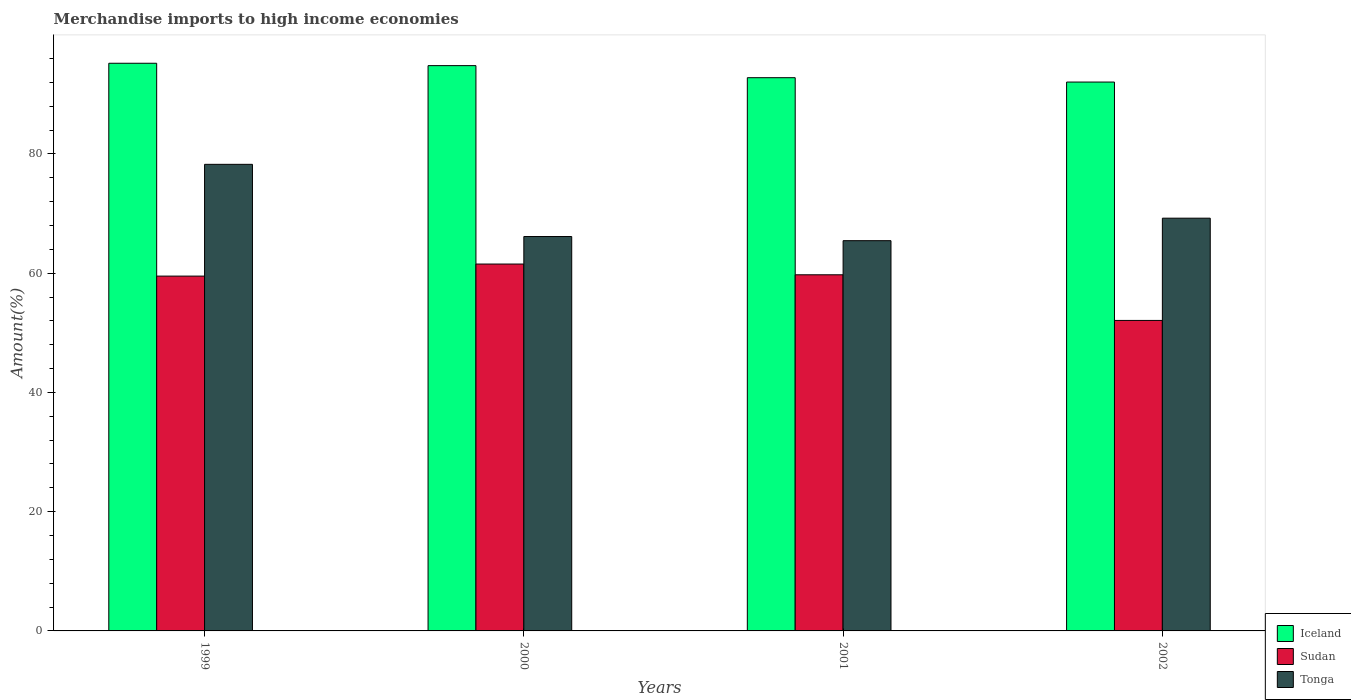How many different coloured bars are there?
Provide a short and direct response. 3. How many groups of bars are there?
Give a very brief answer. 4. Are the number of bars per tick equal to the number of legend labels?
Offer a very short reply. Yes. Are the number of bars on each tick of the X-axis equal?
Provide a short and direct response. Yes. How many bars are there on the 3rd tick from the right?
Keep it short and to the point. 3. What is the label of the 3rd group of bars from the left?
Your answer should be very brief. 2001. In how many cases, is the number of bars for a given year not equal to the number of legend labels?
Give a very brief answer. 0. What is the percentage of amount earned from merchandise imports in Tonga in 2000?
Provide a short and direct response. 66.15. Across all years, what is the maximum percentage of amount earned from merchandise imports in Tonga?
Your response must be concise. 78.26. Across all years, what is the minimum percentage of amount earned from merchandise imports in Iceland?
Your answer should be compact. 92.06. What is the total percentage of amount earned from merchandise imports in Sudan in the graph?
Offer a terse response. 232.85. What is the difference between the percentage of amount earned from merchandise imports in Sudan in 1999 and that in 2002?
Make the answer very short. 7.43. What is the difference between the percentage of amount earned from merchandise imports in Tonga in 2000 and the percentage of amount earned from merchandise imports in Iceland in 1999?
Make the answer very short. -29.06. What is the average percentage of amount earned from merchandise imports in Sudan per year?
Your answer should be compact. 58.21. In the year 2001, what is the difference between the percentage of amount earned from merchandise imports in Sudan and percentage of amount earned from merchandise imports in Iceland?
Provide a succinct answer. -33.05. In how many years, is the percentage of amount earned from merchandise imports in Iceland greater than 84 %?
Offer a very short reply. 4. What is the ratio of the percentage of amount earned from merchandise imports in Tonga in 2001 to that in 2002?
Give a very brief answer. 0.95. Is the difference between the percentage of amount earned from merchandise imports in Sudan in 1999 and 2002 greater than the difference between the percentage of amount earned from merchandise imports in Iceland in 1999 and 2002?
Provide a short and direct response. Yes. What is the difference between the highest and the second highest percentage of amount earned from merchandise imports in Sudan?
Your response must be concise. 1.8. What is the difference between the highest and the lowest percentage of amount earned from merchandise imports in Iceland?
Offer a very short reply. 3.15. In how many years, is the percentage of amount earned from merchandise imports in Sudan greater than the average percentage of amount earned from merchandise imports in Sudan taken over all years?
Give a very brief answer. 3. Is the sum of the percentage of amount earned from merchandise imports in Iceland in 2001 and 2002 greater than the maximum percentage of amount earned from merchandise imports in Sudan across all years?
Provide a succinct answer. Yes. What does the 3rd bar from the left in 2001 represents?
Make the answer very short. Tonga. Does the graph contain any zero values?
Make the answer very short. No. Does the graph contain grids?
Your answer should be very brief. No. Where does the legend appear in the graph?
Provide a short and direct response. Bottom right. What is the title of the graph?
Offer a terse response. Merchandise imports to high income economies. Does "Montenegro" appear as one of the legend labels in the graph?
Make the answer very short. No. What is the label or title of the Y-axis?
Provide a succinct answer. Amount(%). What is the Amount(%) of Iceland in 1999?
Make the answer very short. 95.21. What is the Amount(%) in Sudan in 1999?
Provide a short and direct response. 59.51. What is the Amount(%) of Tonga in 1999?
Your response must be concise. 78.26. What is the Amount(%) of Iceland in 2000?
Offer a very short reply. 94.81. What is the Amount(%) in Sudan in 2000?
Make the answer very short. 61.53. What is the Amount(%) in Tonga in 2000?
Keep it short and to the point. 66.15. What is the Amount(%) in Iceland in 2001?
Give a very brief answer. 92.79. What is the Amount(%) in Sudan in 2001?
Keep it short and to the point. 59.73. What is the Amount(%) of Tonga in 2001?
Offer a very short reply. 65.45. What is the Amount(%) in Iceland in 2002?
Make the answer very short. 92.06. What is the Amount(%) in Sudan in 2002?
Your answer should be compact. 52.08. What is the Amount(%) in Tonga in 2002?
Provide a succinct answer. 69.22. Across all years, what is the maximum Amount(%) of Iceland?
Your answer should be compact. 95.21. Across all years, what is the maximum Amount(%) of Sudan?
Keep it short and to the point. 61.53. Across all years, what is the maximum Amount(%) of Tonga?
Offer a terse response. 78.26. Across all years, what is the minimum Amount(%) of Iceland?
Provide a succinct answer. 92.06. Across all years, what is the minimum Amount(%) of Sudan?
Provide a short and direct response. 52.08. Across all years, what is the minimum Amount(%) in Tonga?
Offer a very short reply. 65.45. What is the total Amount(%) of Iceland in the graph?
Your answer should be compact. 374.86. What is the total Amount(%) in Sudan in the graph?
Offer a very short reply. 232.85. What is the total Amount(%) in Tonga in the graph?
Your response must be concise. 279.08. What is the difference between the Amount(%) of Iceland in 1999 and that in 2000?
Your response must be concise. 0.4. What is the difference between the Amount(%) in Sudan in 1999 and that in 2000?
Offer a very short reply. -2.02. What is the difference between the Amount(%) in Tonga in 1999 and that in 2000?
Your answer should be compact. 12.11. What is the difference between the Amount(%) in Iceland in 1999 and that in 2001?
Ensure brevity in your answer.  2.42. What is the difference between the Amount(%) in Sudan in 1999 and that in 2001?
Make the answer very short. -0.22. What is the difference between the Amount(%) of Tonga in 1999 and that in 2001?
Offer a very short reply. 12.8. What is the difference between the Amount(%) of Iceland in 1999 and that in 2002?
Your answer should be very brief. 3.15. What is the difference between the Amount(%) of Sudan in 1999 and that in 2002?
Your response must be concise. 7.43. What is the difference between the Amount(%) of Tonga in 1999 and that in 2002?
Provide a succinct answer. 9.03. What is the difference between the Amount(%) in Iceland in 2000 and that in 2001?
Provide a short and direct response. 2.02. What is the difference between the Amount(%) of Sudan in 2000 and that in 2001?
Offer a very short reply. 1.8. What is the difference between the Amount(%) in Tonga in 2000 and that in 2001?
Provide a succinct answer. 0.7. What is the difference between the Amount(%) of Iceland in 2000 and that in 2002?
Ensure brevity in your answer.  2.76. What is the difference between the Amount(%) in Sudan in 2000 and that in 2002?
Your response must be concise. 9.46. What is the difference between the Amount(%) in Tonga in 2000 and that in 2002?
Offer a very short reply. -3.08. What is the difference between the Amount(%) of Iceland in 2001 and that in 2002?
Ensure brevity in your answer.  0.73. What is the difference between the Amount(%) in Sudan in 2001 and that in 2002?
Offer a very short reply. 7.66. What is the difference between the Amount(%) of Tonga in 2001 and that in 2002?
Make the answer very short. -3.77. What is the difference between the Amount(%) of Iceland in 1999 and the Amount(%) of Sudan in 2000?
Your answer should be compact. 33.67. What is the difference between the Amount(%) of Iceland in 1999 and the Amount(%) of Tonga in 2000?
Your answer should be compact. 29.06. What is the difference between the Amount(%) of Sudan in 1999 and the Amount(%) of Tonga in 2000?
Provide a succinct answer. -6.64. What is the difference between the Amount(%) in Iceland in 1999 and the Amount(%) in Sudan in 2001?
Ensure brevity in your answer.  35.48. What is the difference between the Amount(%) of Iceland in 1999 and the Amount(%) of Tonga in 2001?
Offer a terse response. 29.76. What is the difference between the Amount(%) of Sudan in 1999 and the Amount(%) of Tonga in 2001?
Keep it short and to the point. -5.94. What is the difference between the Amount(%) in Iceland in 1999 and the Amount(%) in Sudan in 2002?
Give a very brief answer. 43.13. What is the difference between the Amount(%) of Iceland in 1999 and the Amount(%) of Tonga in 2002?
Make the answer very short. 25.98. What is the difference between the Amount(%) in Sudan in 1999 and the Amount(%) in Tonga in 2002?
Your answer should be compact. -9.71. What is the difference between the Amount(%) in Iceland in 2000 and the Amount(%) in Sudan in 2001?
Your response must be concise. 35.08. What is the difference between the Amount(%) in Iceland in 2000 and the Amount(%) in Tonga in 2001?
Give a very brief answer. 29.36. What is the difference between the Amount(%) of Sudan in 2000 and the Amount(%) of Tonga in 2001?
Make the answer very short. -3.92. What is the difference between the Amount(%) of Iceland in 2000 and the Amount(%) of Sudan in 2002?
Provide a short and direct response. 42.73. What is the difference between the Amount(%) of Iceland in 2000 and the Amount(%) of Tonga in 2002?
Keep it short and to the point. 25.59. What is the difference between the Amount(%) in Sudan in 2000 and the Amount(%) in Tonga in 2002?
Ensure brevity in your answer.  -7.69. What is the difference between the Amount(%) of Iceland in 2001 and the Amount(%) of Sudan in 2002?
Give a very brief answer. 40.71. What is the difference between the Amount(%) of Iceland in 2001 and the Amount(%) of Tonga in 2002?
Offer a terse response. 23.56. What is the difference between the Amount(%) of Sudan in 2001 and the Amount(%) of Tonga in 2002?
Make the answer very short. -9.49. What is the average Amount(%) of Iceland per year?
Give a very brief answer. 93.72. What is the average Amount(%) of Sudan per year?
Provide a short and direct response. 58.21. What is the average Amount(%) in Tonga per year?
Your answer should be compact. 69.77. In the year 1999, what is the difference between the Amount(%) in Iceland and Amount(%) in Sudan?
Give a very brief answer. 35.7. In the year 1999, what is the difference between the Amount(%) of Iceland and Amount(%) of Tonga?
Offer a terse response. 16.95. In the year 1999, what is the difference between the Amount(%) of Sudan and Amount(%) of Tonga?
Keep it short and to the point. -18.75. In the year 2000, what is the difference between the Amount(%) in Iceland and Amount(%) in Sudan?
Offer a terse response. 33.28. In the year 2000, what is the difference between the Amount(%) in Iceland and Amount(%) in Tonga?
Make the answer very short. 28.66. In the year 2000, what is the difference between the Amount(%) in Sudan and Amount(%) in Tonga?
Offer a very short reply. -4.61. In the year 2001, what is the difference between the Amount(%) of Iceland and Amount(%) of Sudan?
Keep it short and to the point. 33.05. In the year 2001, what is the difference between the Amount(%) of Iceland and Amount(%) of Tonga?
Offer a very short reply. 27.33. In the year 2001, what is the difference between the Amount(%) in Sudan and Amount(%) in Tonga?
Give a very brief answer. -5.72. In the year 2002, what is the difference between the Amount(%) of Iceland and Amount(%) of Sudan?
Ensure brevity in your answer.  39.98. In the year 2002, what is the difference between the Amount(%) of Iceland and Amount(%) of Tonga?
Offer a terse response. 22.83. In the year 2002, what is the difference between the Amount(%) in Sudan and Amount(%) in Tonga?
Provide a succinct answer. -17.15. What is the ratio of the Amount(%) of Sudan in 1999 to that in 2000?
Offer a terse response. 0.97. What is the ratio of the Amount(%) of Tonga in 1999 to that in 2000?
Give a very brief answer. 1.18. What is the ratio of the Amount(%) of Iceland in 1999 to that in 2001?
Your answer should be compact. 1.03. What is the ratio of the Amount(%) of Tonga in 1999 to that in 2001?
Provide a succinct answer. 1.2. What is the ratio of the Amount(%) of Iceland in 1999 to that in 2002?
Your answer should be very brief. 1.03. What is the ratio of the Amount(%) of Sudan in 1999 to that in 2002?
Your answer should be very brief. 1.14. What is the ratio of the Amount(%) in Tonga in 1999 to that in 2002?
Provide a short and direct response. 1.13. What is the ratio of the Amount(%) in Iceland in 2000 to that in 2001?
Your answer should be very brief. 1.02. What is the ratio of the Amount(%) in Sudan in 2000 to that in 2001?
Provide a succinct answer. 1.03. What is the ratio of the Amount(%) in Tonga in 2000 to that in 2001?
Make the answer very short. 1.01. What is the ratio of the Amount(%) in Iceland in 2000 to that in 2002?
Your answer should be very brief. 1.03. What is the ratio of the Amount(%) in Sudan in 2000 to that in 2002?
Offer a very short reply. 1.18. What is the ratio of the Amount(%) of Tonga in 2000 to that in 2002?
Provide a succinct answer. 0.96. What is the ratio of the Amount(%) in Iceland in 2001 to that in 2002?
Ensure brevity in your answer.  1.01. What is the ratio of the Amount(%) of Sudan in 2001 to that in 2002?
Your answer should be very brief. 1.15. What is the ratio of the Amount(%) of Tonga in 2001 to that in 2002?
Provide a succinct answer. 0.95. What is the difference between the highest and the second highest Amount(%) in Iceland?
Make the answer very short. 0.4. What is the difference between the highest and the second highest Amount(%) of Sudan?
Offer a very short reply. 1.8. What is the difference between the highest and the second highest Amount(%) in Tonga?
Make the answer very short. 9.03. What is the difference between the highest and the lowest Amount(%) of Iceland?
Offer a very short reply. 3.15. What is the difference between the highest and the lowest Amount(%) in Sudan?
Your response must be concise. 9.46. What is the difference between the highest and the lowest Amount(%) of Tonga?
Your answer should be very brief. 12.8. 